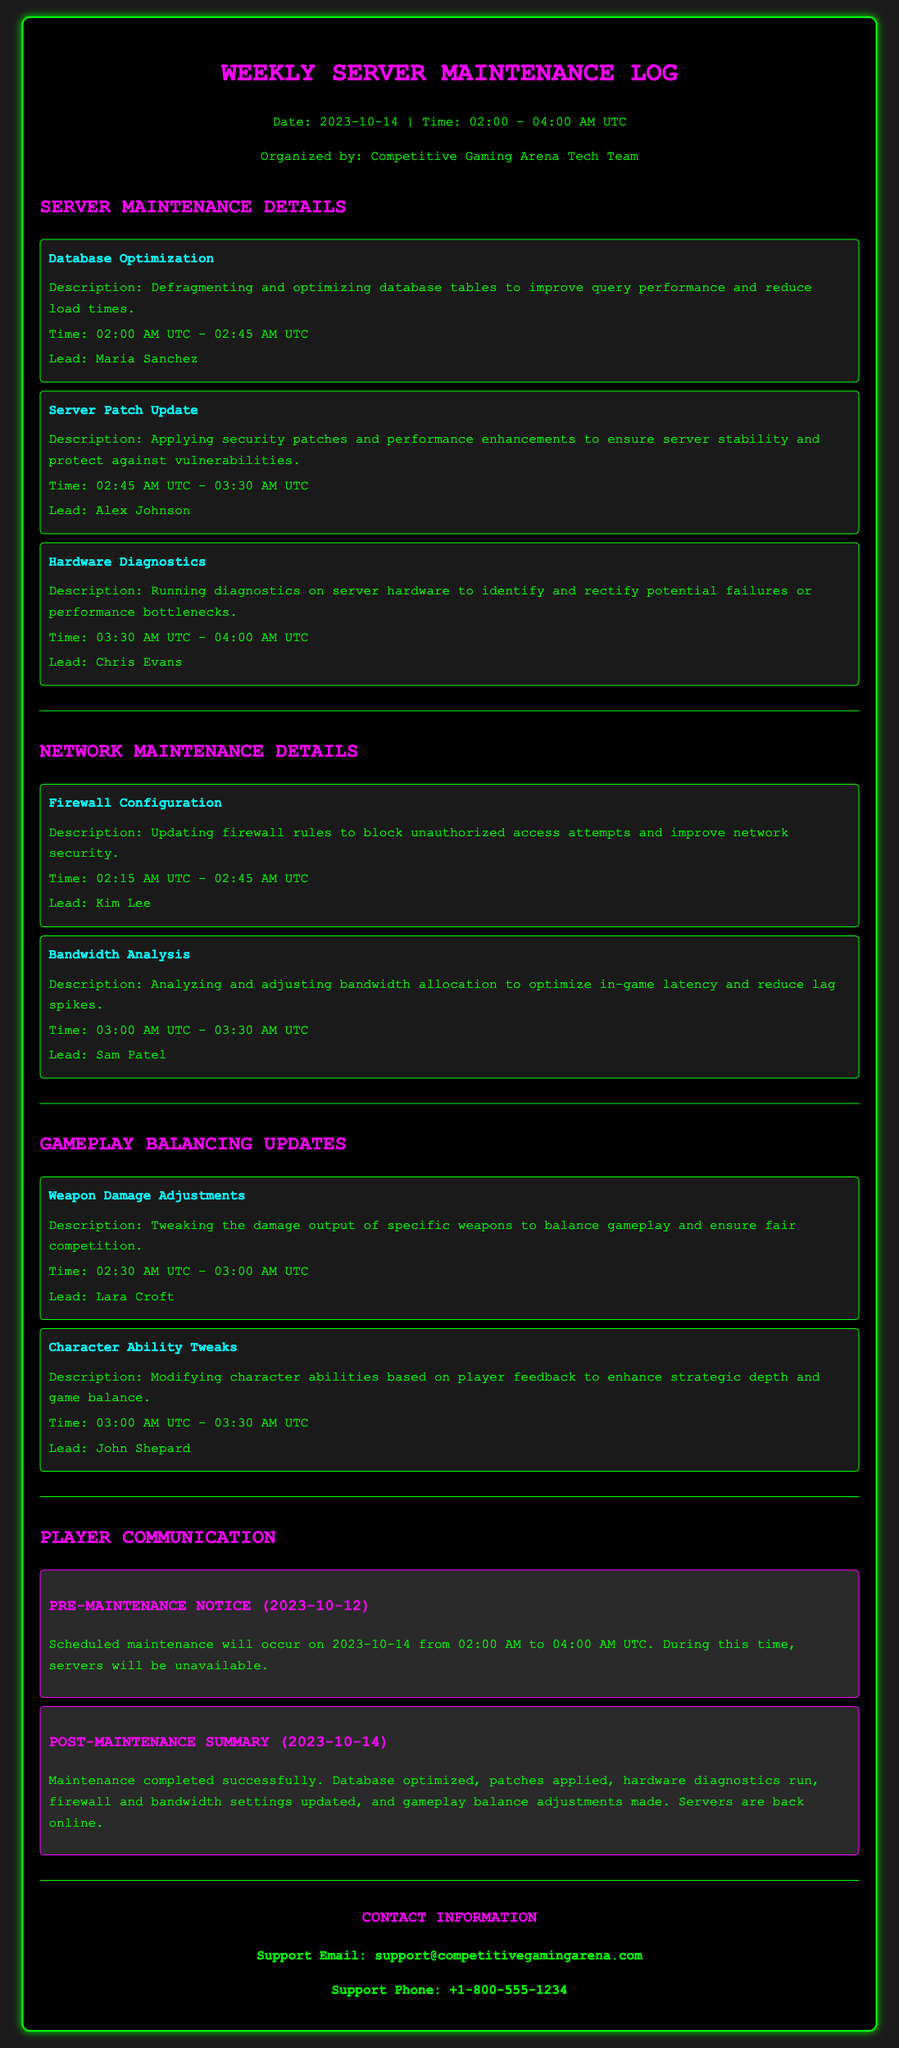what is the date of the maintenance? The date of the maintenance is provided in the header section, stating it occurs on 2023-10-14.
Answer: 2023-10-14 who led the database optimization task? The document specifies the lead for the database optimization task, which is Maria Sanchez.
Answer: Maria Sanchez what was the time frame for the server patch update? The time frame for the server patch update is detailed in the task description, listing it from 02:45 AM UTC to 03:30 AM UTC.
Answer: 02:45 AM UTC - 03:30 AM UTC how many tasks were focused on gameplay balancing updates? Counting the tasks listed under gameplay balancing updates, there are two tasks shown.
Answer: 2 what type of analysis was conducted on bandwidth? The document states that bandwidth analysis was performed to optimize in-game latency and reduce lag spikes.
Answer: Bandwidth Analysis when was the pre-maintenance notice issued? The document contains a specific date for the pre-maintenance notice as 2023-10-12.
Answer: 2023-10-12 who was responsible for the firewall configuration? The lead for the firewall configuration is identified as Kim Lee in the maintenance log.
Answer: Kim Lee what is the contact email for support? The document provides a clear support email address for inquiries, which is support@competitivegamingarena.com.
Answer: support@competitivegamingarena.com 